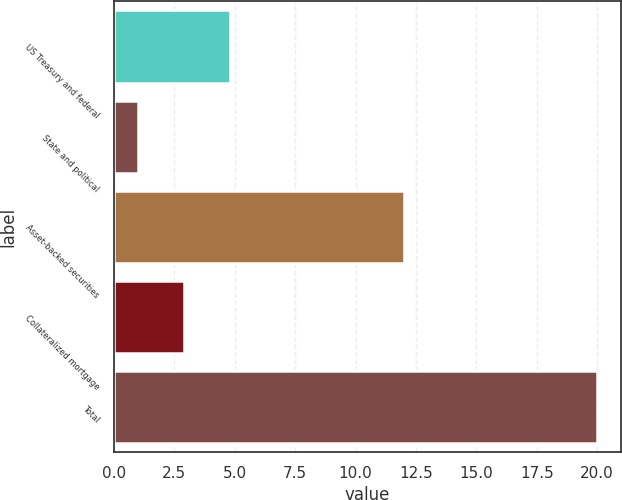Convert chart to OTSL. <chart><loc_0><loc_0><loc_500><loc_500><bar_chart><fcel>US Treasury and federal<fcel>State and political<fcel>Asset-backed securities<fcel>Collateralized mortgage<fcel>Total<nl><fcel>4.8<fcel>1<fcel>12<fcel>2.9<fcel>20<nl></chart> 